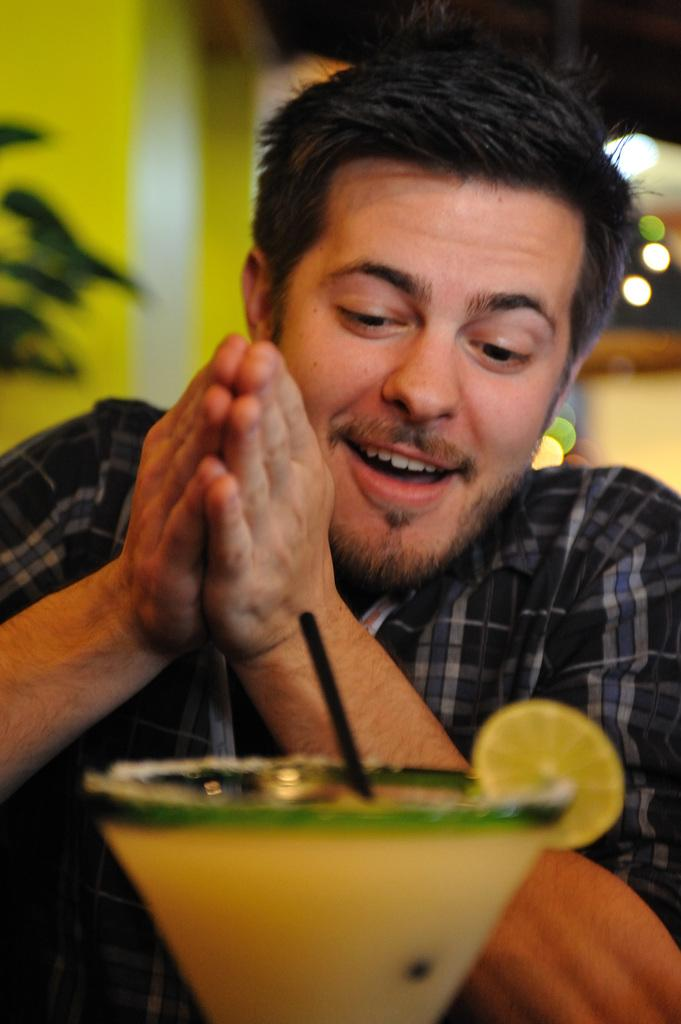What is present in the image? There is a person, juice in a glass, a wall, and a straw in the glass. Can you describe the person in the image? The provided facts do not give any details about the person's appearance or actions. What is the person holding or using in the image? The person is not holding or using anything mentioned in the provided facts. What is the purpose of the straw in the glass? The straw is likely used for drinking the juice in the glass. What type of wine is being served at the border in the image? There is no mention of wine or a border in the provided facts, and therefore no such activity can be observed. 